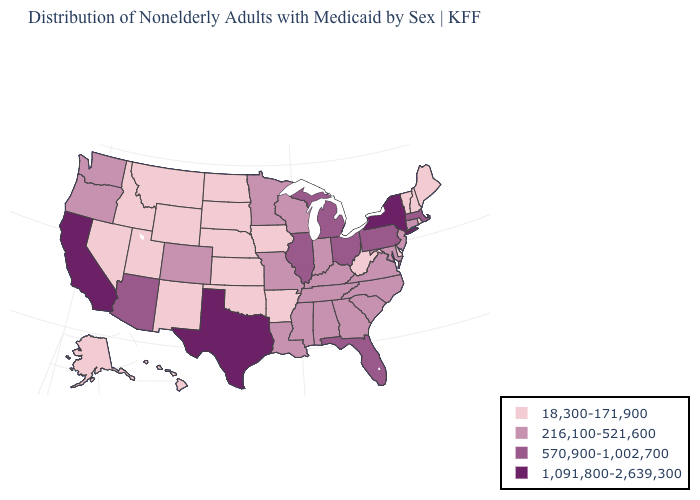Does Maine have the lowest value in the USA?
Short answer required. Yes. Name the states that have a value in the range 216,100-521,600?
Answer briefly. Alabama, Colorado, Connecticut, Georgia, Indiana, Kentucky, Louisiana, Maryland, Minnesota, Mississippi, Missouri, New Jersey, North Carolina, Oregon, South Carolina, Tennessee, Virginia, Washington, Wisconsin. What is the value of Arizona?
Short answer required. 570,900-1,002,700. Name the states that have a value in the range 1,091,800-2,639,300?
Short answer required. California, New York, Texas. What is the lowest value in states that border Delaware?
Short answer required. 216,100-521,600. Name the states that have a value in the range 570,900-1,002,700?
Quick response, please. Arizona, Florida, Illinois, Massachusetts, Michigan, Ohio, Pennsylvania. Name the states that have a value in the range 18,300-171,900?
Be succinct. Alaska, Arkansas, Delaware, Hawaii, Idaho, Iowa, Kansas, Maine, Montana, Nebraska, Nevada, New Hampshire, New Mexico, North Dakota, Oklahoma, Rhode Island, South Dakota, Utah, Vermont, West Virginia, Wyoming. What is the value of Nebraska?
Quick response, please. 18,300-171,900. What is the value of New Hampshire?
Give a very brief answer. 18,300-171,900. Name the states that have a value in the range 570,900-1,002,700?
Give a very brief answer. Arizona, Florida, Illinois, Massachusetts, Michigan, Ohio, Pennsylvania. What is the value of California?
Quick response, please. 1,091,800-2,639,300. What is the value of New Hampshire?
Short answer required. 18,300-171,900. What is the value of Nebraska?
Be succinct. 18,300-171,900. Does Kentucky have the same value as Michigan?
Keep it brief. No. What is the lowest value in states that border Massachusetts?
Concise answer only. 18,300-171,900. 